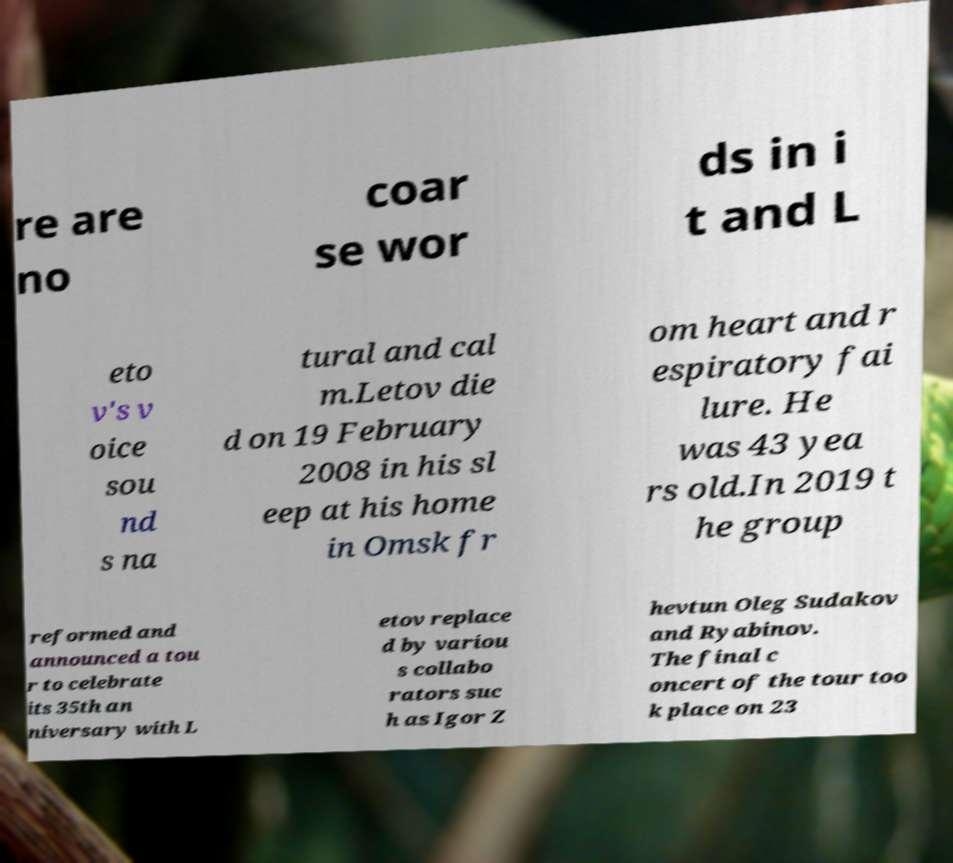Please read and relay the text visible in this image. What does it say? re are no coar se wor ds in i t and L eto v's v oice sou nd s na tural and cal m.Letov die d on 19 February 2008 in his sl eep at his home in Omsk fr om heart and r espiratory fai lure. He was 43 yea rs old.In 2019 t he group reformed and announced a tou r to celebrate its 35th an niversary with L etov replace d by variou s collabo rators suc h as Igor Z hevtun Oleg Sudakov and Ryabinov. The final c oncert of the tour too k place on 23 